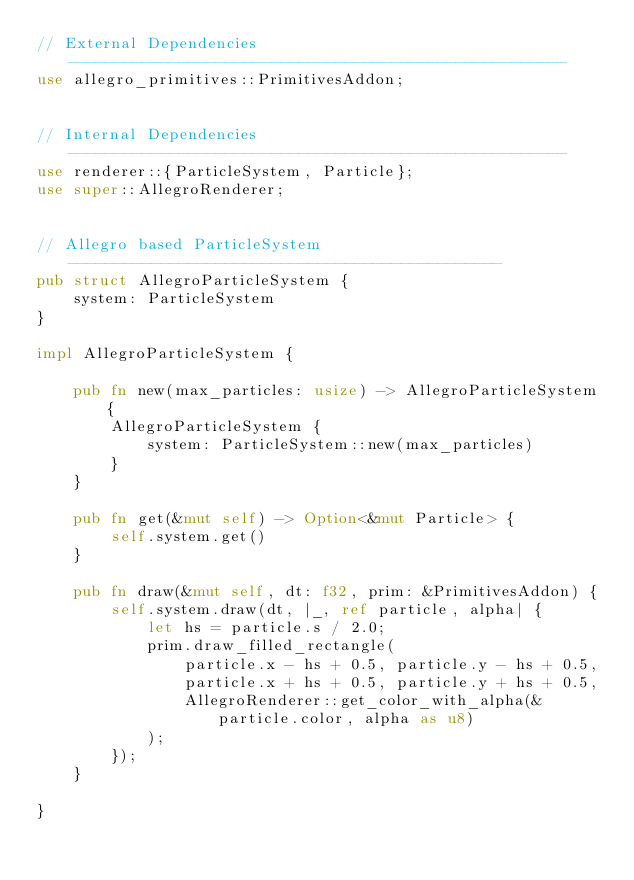Convert code to text. <code><loc_0><loc_0><loc_500><loc_500><_Rust_>// External Dependencies ------------------------------------------------------
use allegro_primitives::PrimitivesAddon;


// Internal Dependencies ------------------------------------------------------
use renderer::{ParticleSystem, Particle};
use super::AllegroRenderer;


// Allegro based ParticleSystem -----------------------------------------------
pub struct AllegroParticleSystem {
    system: ParticleSystem
}

impl AllegroParticleSystem {

    pub fn new(max_particles: usize) -> AllegroParticleSystem {
        AllegroParticleSystem {
            system: ParticleSystem::new(max_particles)
        }
    }

    pub fn get(&mut self) -> Option<&mut Particle> {
        self.system.get()
    }

    pub fn draw(&mut self, dt: f32, prim: &PrimitivesAddon) {
        self.system.draw(dt, |_, ref particle, alpha| {
            let hs = particle.s / 2.0;
            prim.draw_filled_rectangle(
                particle.x - hs + 0.5, particle.y - hs + 0.5,
                particle.x + hs + 0.5, particle.y + hs + 0.5,
                AllegroRenderer::get_color_with_alpha(&particle.color, alpha as u8)
            );
        });
    }

}

</code> 